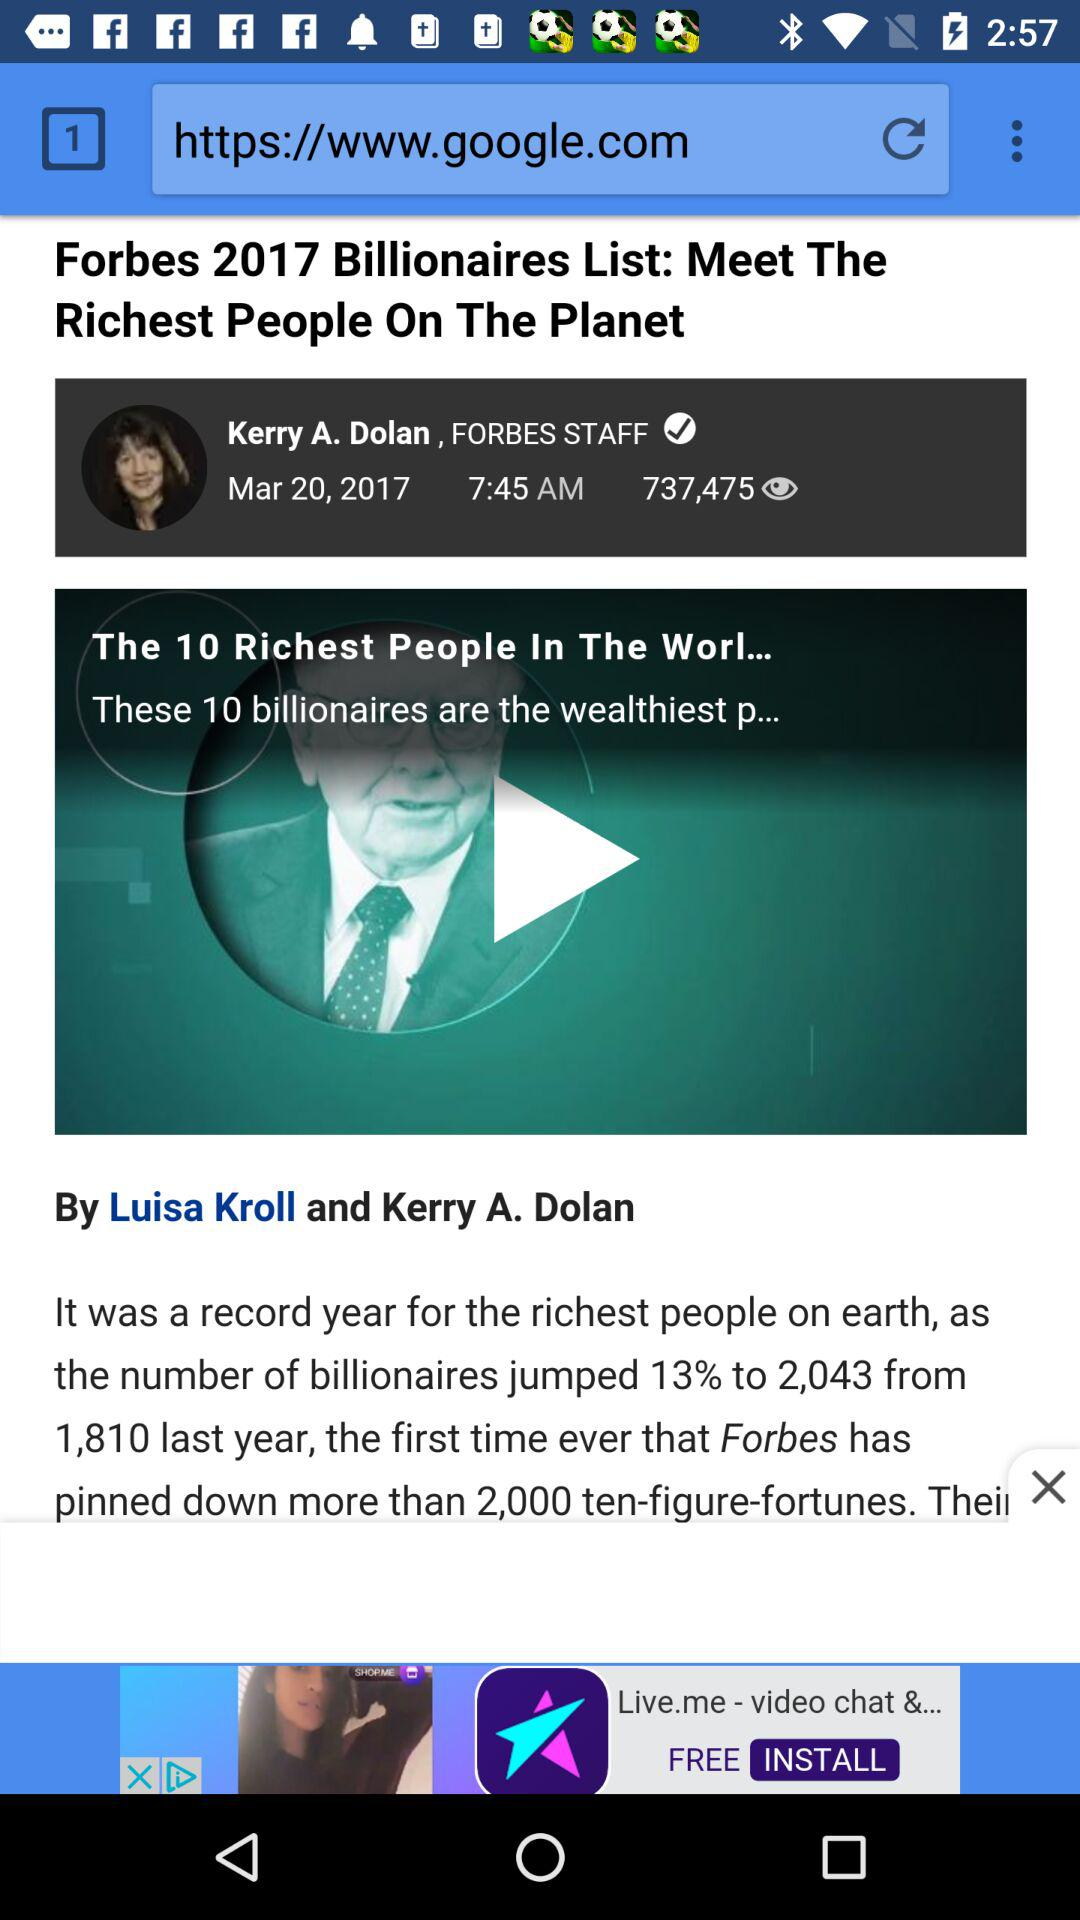By whom was the video posted? The video was posted by Kerry A. Dolan. 